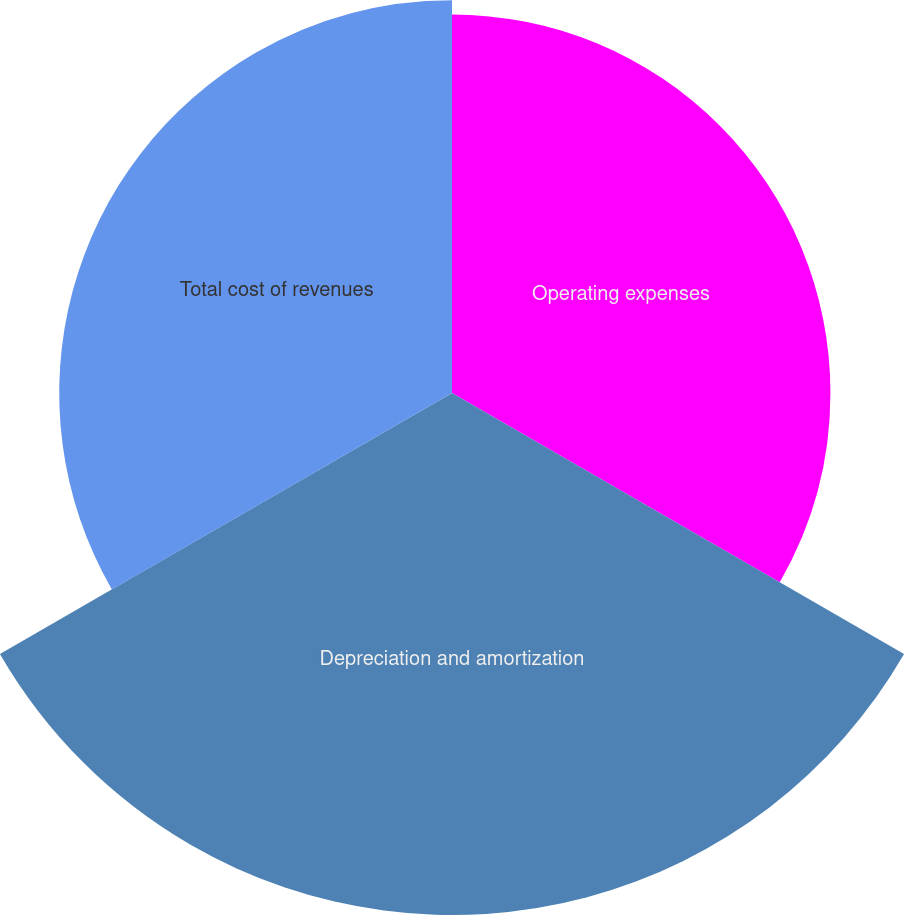<chart> <loc_0><loc_0><loc_500><loc_500><pie_chart><fcel>Operating expenses<fcel>Depreciation and amortization<fcel>Total cost of revenues<nl><fcel>29.26%<fcel>40.36%<fcel>30.37%<nl></chart> 